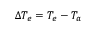Convert formula to latex. <formula><loc_0><loc_0><loc_500><loc_500>\Delta T _ { e } = T _ { e } - T _ { a }</formula> 